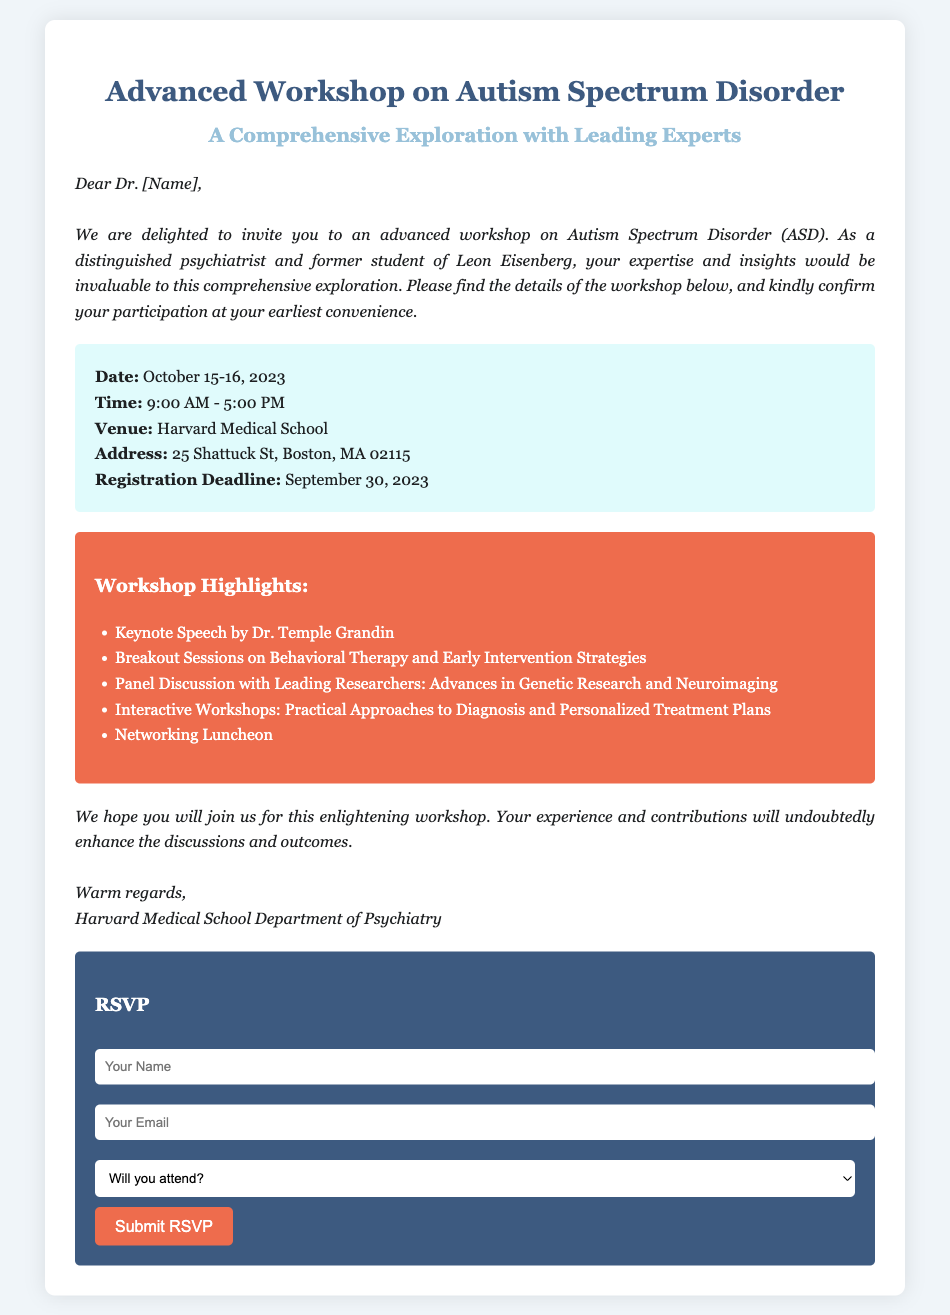What are the dates of the workshop? The dates of the workshop are specified in the details section of the document.
Answer: October 15-16, 2023 What time does the workshop start? The start time of the workshop is mentioned in the details section.
Answer: 9:00 AM What is the registration deadline? The registration deadline is provided in the details section.
Answer: September 30, 2023 Who is giving the keynote speech? The keynote speaker is listed in the workshop highlights.
Answer: Dr. Temple Grandin What venue is hosting the workshop? The venue information is included in the details section.
Answer: Harvard Medical School What type of sessions are included in the workshop? The type of sessions can be inferred from the highlights provided in the document.
Answer: Breakout Sessions Will there be networking opportunities? The document mentions networking as part of the workshop activities.
Answer: Yes What is the purpose of the RSVP form? The RSVP form is implied to gather responses about attendance to the workshop.
Answer: Confirm attendance How should attendees submit their RSVP? The method of RSVP submission is described in the RSVP form section.
Answer: Online form submission 